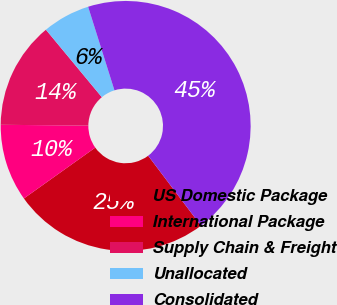Convert chart to OTSL. <chart><loc_0><loc_0><loc_500><loc_500><pie_chart><fcel>US Domestic Package<fcel>International Package<fcel>Supply Chain & Freight<fcel>Unallocated<fcel>Consolidated<nl><fcel>25.44%<fcel>10.0%<fcel>13.84%<fcel>6.16%<fcel>44.57%<nl></chart> 